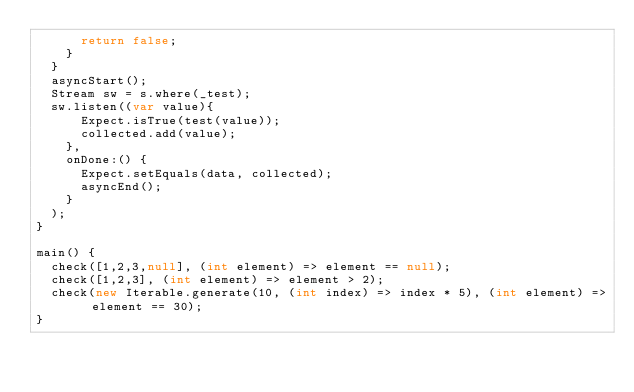<code> <loc_0><loc_0><loc_500><loc_500><_Dart_>      return false;
    }
  }
  asyncStart();
  Stream sw = s.where(_test);
  sw.listen((var value){
      Expect.isTrue(test(value));
      collected.add(value);
    },
    onDone:() {
      Expect.setEquals(data, collected);
      asyncEnd();
    }
  );
}

main() {
  check([1,2,3,null], (int element) => element == null);
  check([1,2,3], (int element) => element > 2);
  check(new Iterable.generate(10, (int index) => index * 5), (int element) => element == 30);
}
</code> 